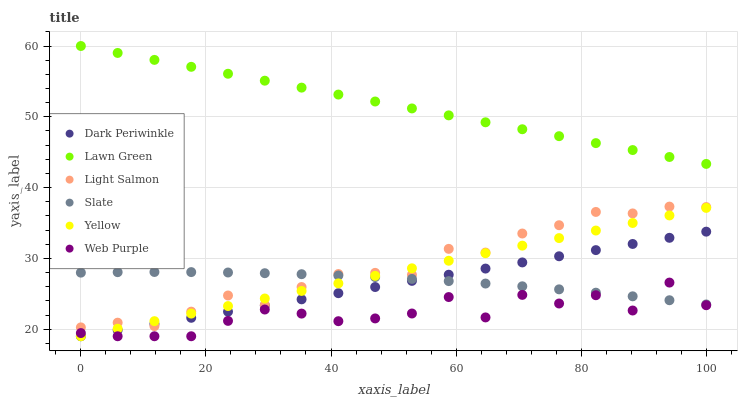Does Web Purple have the minimum area under the curve?
Answer yes or no. Yes. Does Lawn Green have the maximum area under the curve?
Answer yes or no. Yes. Does Light Salmon have the minimum area under the curve?
Answer yes or no. No. Does Light Salmon have the maximum area under the curve?
Answer yes or no. No. Is Dark Periwinkle the smoothest?
Answer yes or no. Yes. Is Web Purple the roughest?
Answer yes or no. Yes. Is Light Salmon the smoothest?
Answer yes or no. No. Is Light Salmon the roughest?
Answer yes or no. No. Does Yellow have the lowest value?
Answer yes or no. Yes. Does Light Salmon have the lowest value?
Answer yes or no. No. Does Lawn Green have the highest value?
Answer yes or no. Yes. Does Light Salmon have the highest value?
Answer yes or no. No. Is Dark Periwinkle less than Lawn Green?
Answer yes or no. Yes. Is Lawn Green greater than Dark Periwinkle?
Answer yes or no. Yes. Does Dark Periwinkle intersect Web Purple?
Answer yes or no. Yes. Is Dark Periwinkle less than Web Purple?
Answer yes or no. No. Is Dark Periwinkle greater than Web Purple?
Answer yes or no. No. Does Dark Periwinkle intersect Lawn Green?
Answer yes or no. No. 